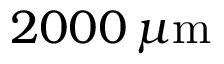Convert formula to latex. <formula><loc_0><loc_0><loc_500><loc_500>2 0 0 0 \, \mu m</formula> 